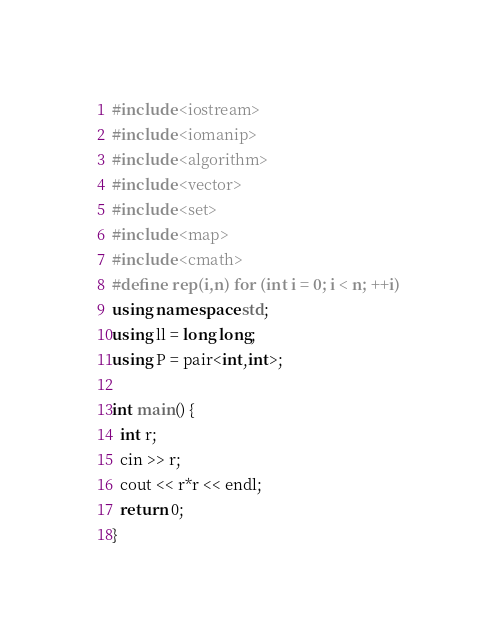<code> <loc_0><loc_0><loc_500><loc_500><_C++_>#include <iostream>
#include <iomanip>
#include <algorithm>
#include <vector>
#include <set>
#include <map>
#include <cmath>
#define rep(i,n) for (int i = 0; i < n; ++i)
using namespace std;
using ll = long long;
using P = pair<int,int>;

int main() {
  int r;
  cin >> r;
  cout << r*r << endl;
  return 0;
}</code> 